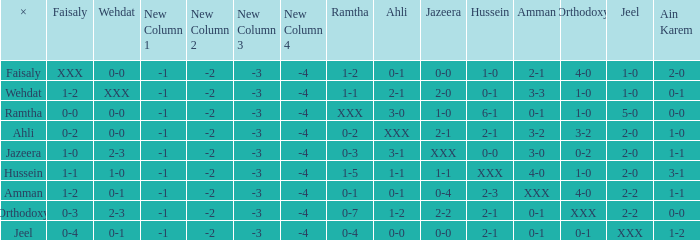What is faisaly when wehdat is xxx? 1-2. 